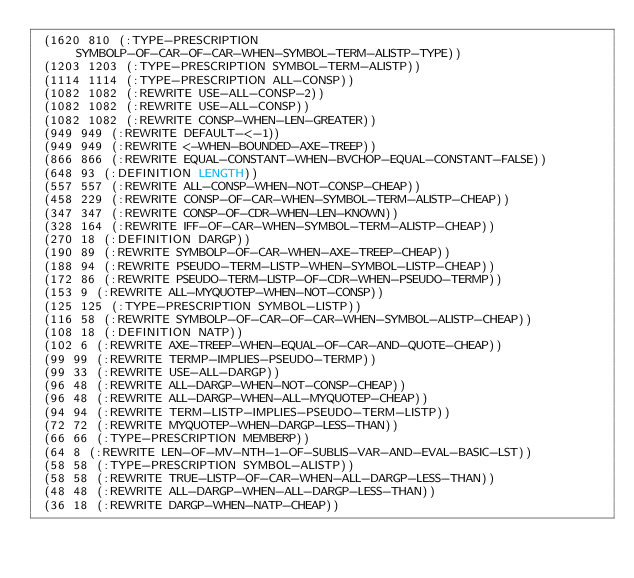Convert code to text. <code><loc_0><loc_0><loc_500><loc_500><_Lisp_> (1620 810 (:TYPE-PRESCRIPTION SYMBOLP-OF-CAR-OF-CAR-WHEN-SYMBOL-TERM-ALISTP-TYPE))
 (1203 1203 (:TYPE-PRESCRIPTION SYMBOL-TERM-ALISTP))
 (1114 1114 (:TYPE-PRESCRIPTION ALL-CONSP))
 (1082 1082 (:REWRITE USE-ALL-CONSP-2))
 (1082 1082 (:REWRITE USE-ALL-CONSP))
 (1082 1082 (:REWRITE CONSP-WHEN-LEN-GREATER))
 (949 949 (:REWRITE DEFAULT-<-1))
 (949 949 (:REWRITE <-WHEN-BOUNDED-AXE-TREEP))
 (866 866 (:REWRITE EQUAL-CONSTANT-WHEN-BVCHOP-EQUAL-CONSTANT-FALSE))
 (648 93 (:DEFINITION LENGTH))
 (557 557 (:REWRITE ALL-CONSP-WHEN-NOT-CONSP-CHEAP))
 (458 229 (:REWRITE CONSP-OF-CAR-WHEN-SYMBOL-TERM-ALISTP-CHEAP))
 (347 347 (:REWRITE CONSP-OF-CDR-WHEN-LEN-KNOWN))
 (328 164 (:REWRITE IFF-OF-CAR-WHEN-SYMBOL-TERM-ALISTP-CHEAP))
 (270 18 (:DEFINITION DARGP))
 (190 89 (:REWRITE SYMBOLP-OF-CAR-WHEN-AXE-TREEP-CHEAP))
 (188 94 (:REWRITE PSEUDO-TERM-LISTP-WHEN-SYMBOL-LISTP-CHEAP))
 (172 86 (:REWRITE PSEUDO-TERM-LISTP-OF-CDR-WHEN-PSEUDO-TERMP))
 (153 9 (:REWRITE ALL-MYQUOTEP-WHEN-NOT-CONSP))
 (125 125 (:TYPE-PRESCRIPTION SYMBOL-LISTP))
 (116 58 (:REWRITE SYMBOLP-OF-CAR-OF-CAR-WHEN-SYMBOL-ALISTP-CHEAP))
 (108 18 (:DEFINITION NATP))
 (102 6 (:REWRITE AXE-TREEP-WHEN-EQUAL-OF-CAR-AND-QUOTE-CHEAP))
 (99 99 (:REWRITE TERMP-IMPLIES-PSEUDO-TERMP))
 (99 33 (:REWRITE USE-ALL-DARGP))
 (96 48 (:REWRITE ALL-DARGP-WHEN-NOT-CONSP-CHEAP))
 (96 48 (:REWRITE ALL-DARGP-WHEN-ALL-MYQUOTEP-CHEAP))
 (94 94 (:REWRITE TERM-LISTP-IMPLIES-PSEUDO-TERM-LISTP))
 (72 72 (:REWRITE MYQUOTEP-WHEN-DARGP-LESS-THAN))
 (66 66 (:TYPE-PRESCRIPTION MEMBERP))
 (64 8 (:REWRITE LEN-OF-MV-NTH-1-OF-SUBLIS-VAR-AND-EVAL-BASIC-LST))
 (58 58 (:TYPE-PRESCRIPTION SYMBOL-ALISTP))
 (58 58 (:REWRITE TRUE-LISTP-OF-CAR-WHEN-ALL-DARGP-LESS-THAN))
 (48 48 (:REWRITE ALL-DARGP-WHEN-ALL-DARGP-LESS-THAN))
 (36 18 (:REWRITE DARGP-WHEN-NATP-CHEAP))</code> 